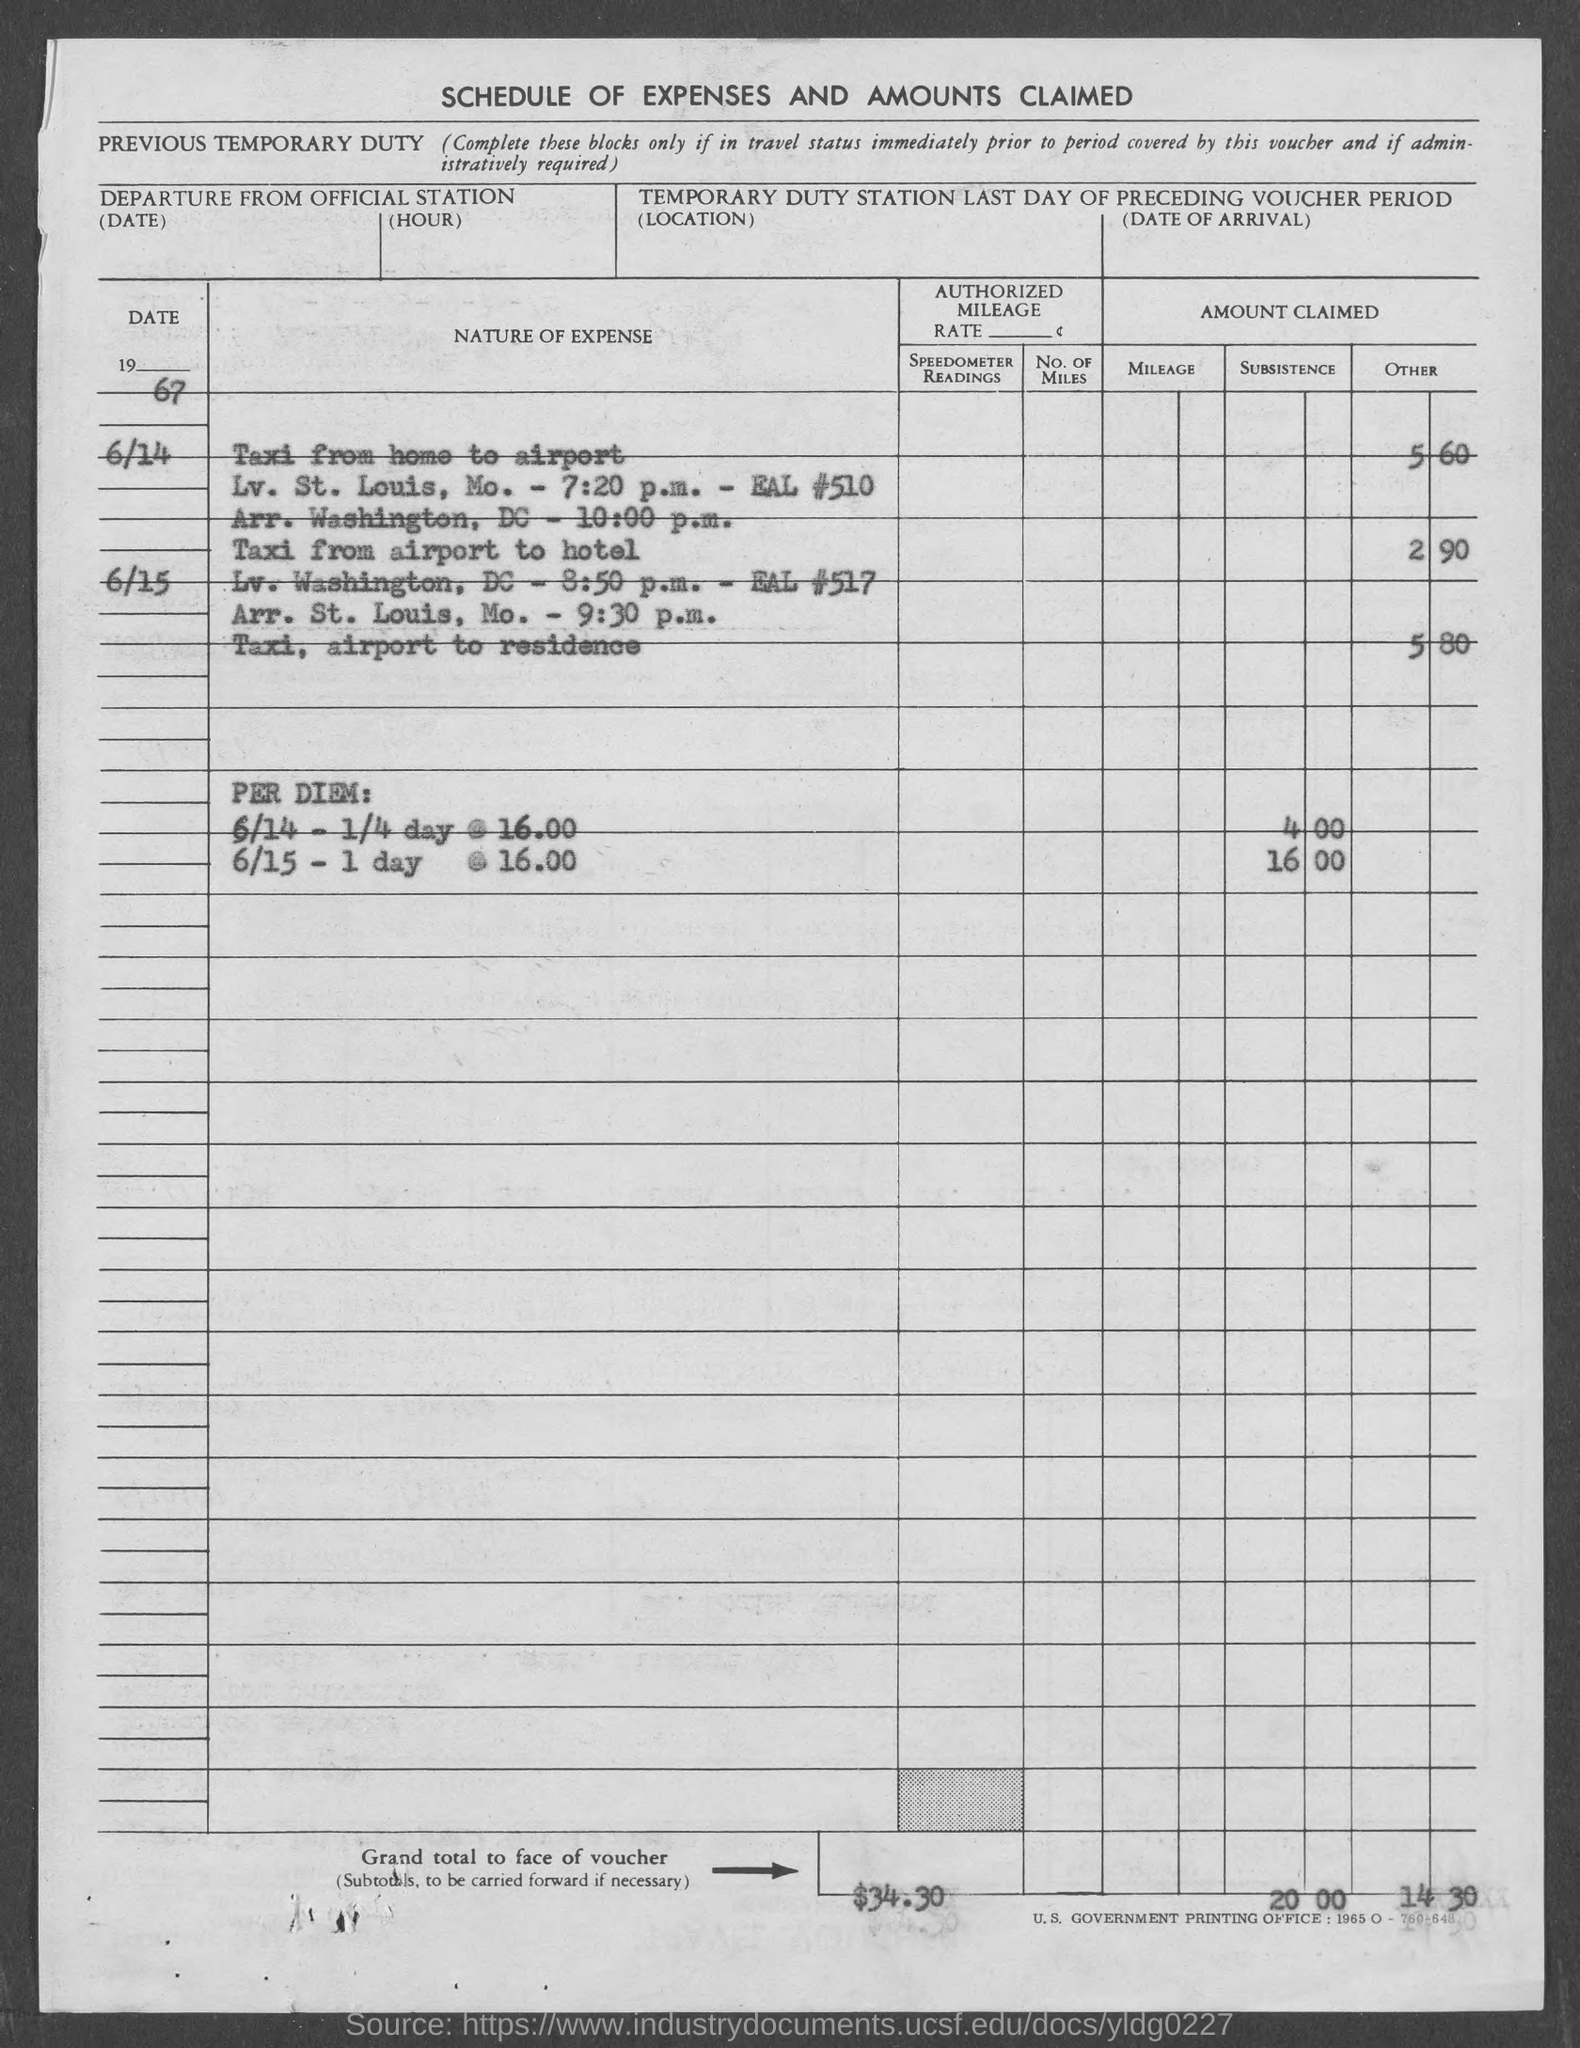What is the grand total in voucher ?
Your answer should be compact. $34.30. 